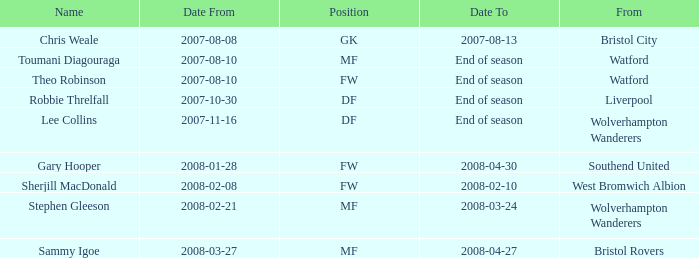What was the from for the Date From of 2007-08-08? Bristol City. 